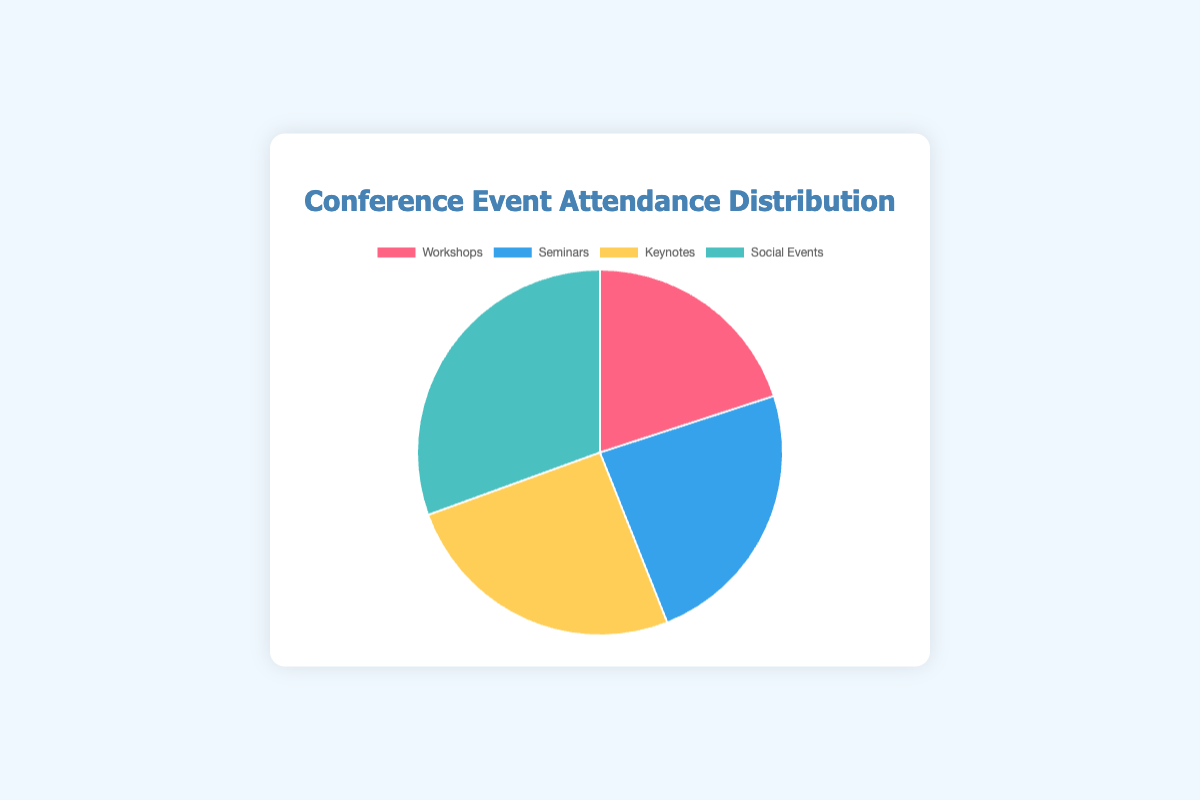Which event type had the highest attendance? The pie chart shows the total attendance for each event type. Social Events had the largest slice, indicating the highest attendance.
Answer: Social Events Which event type had the smallest attendance? The chart indicates that Workshops had the smallest slice, representing the lowest attendance.
Answer: Workshops How does the attendance at Social Events compare to Keynotes? Visually, the slice representing Social Events is larger than that for Keynotes, indicating higher attendance at Social Events.
Answer: Higher What is the percentage of total attendance accounted for by Seminars? The tooltip in the chart indicates the percentage for each event type. Seminars account for approximately 30.7% of total attendance.
Answer: 30.7% What is the combined attendance of Seminars and Keynotes? The segments for Seminars and Keynotes show their respective attendances (660 and 700). Adding these gives a total of 1360.
Answer: 1360 What is the difference in attendance between Workshops and Seminars? Calculate the total attendance for Workshops (550) and Seminars (660), then subtract the smaller total from the larger: 660 - 550 = 110.
Answer: 110 Which event type had more attendance: "Hands-on Python Programming" or "Cybersecurity Trends"? "Cybersecurity Trends" had a larger attendance (160) compared to "Hands-on Python Programming" (120), as indicated in the data.
Answer: Cybersecurity Trends If you combined the attendance of all Workshop events, would it exceed the attendance of Social Events? Workshops have a combined attendance of 550. Social Events have a combined attendance of 840. Therefore, Workshops are less.
Answer: No What is the average attendance per event for Keynotes? The total attendance for Keynotes is 700, and there are 3 events. So, the average attendance per Keynote event is 700 / 3 ≈ 233.3.
Answer: 233.3 